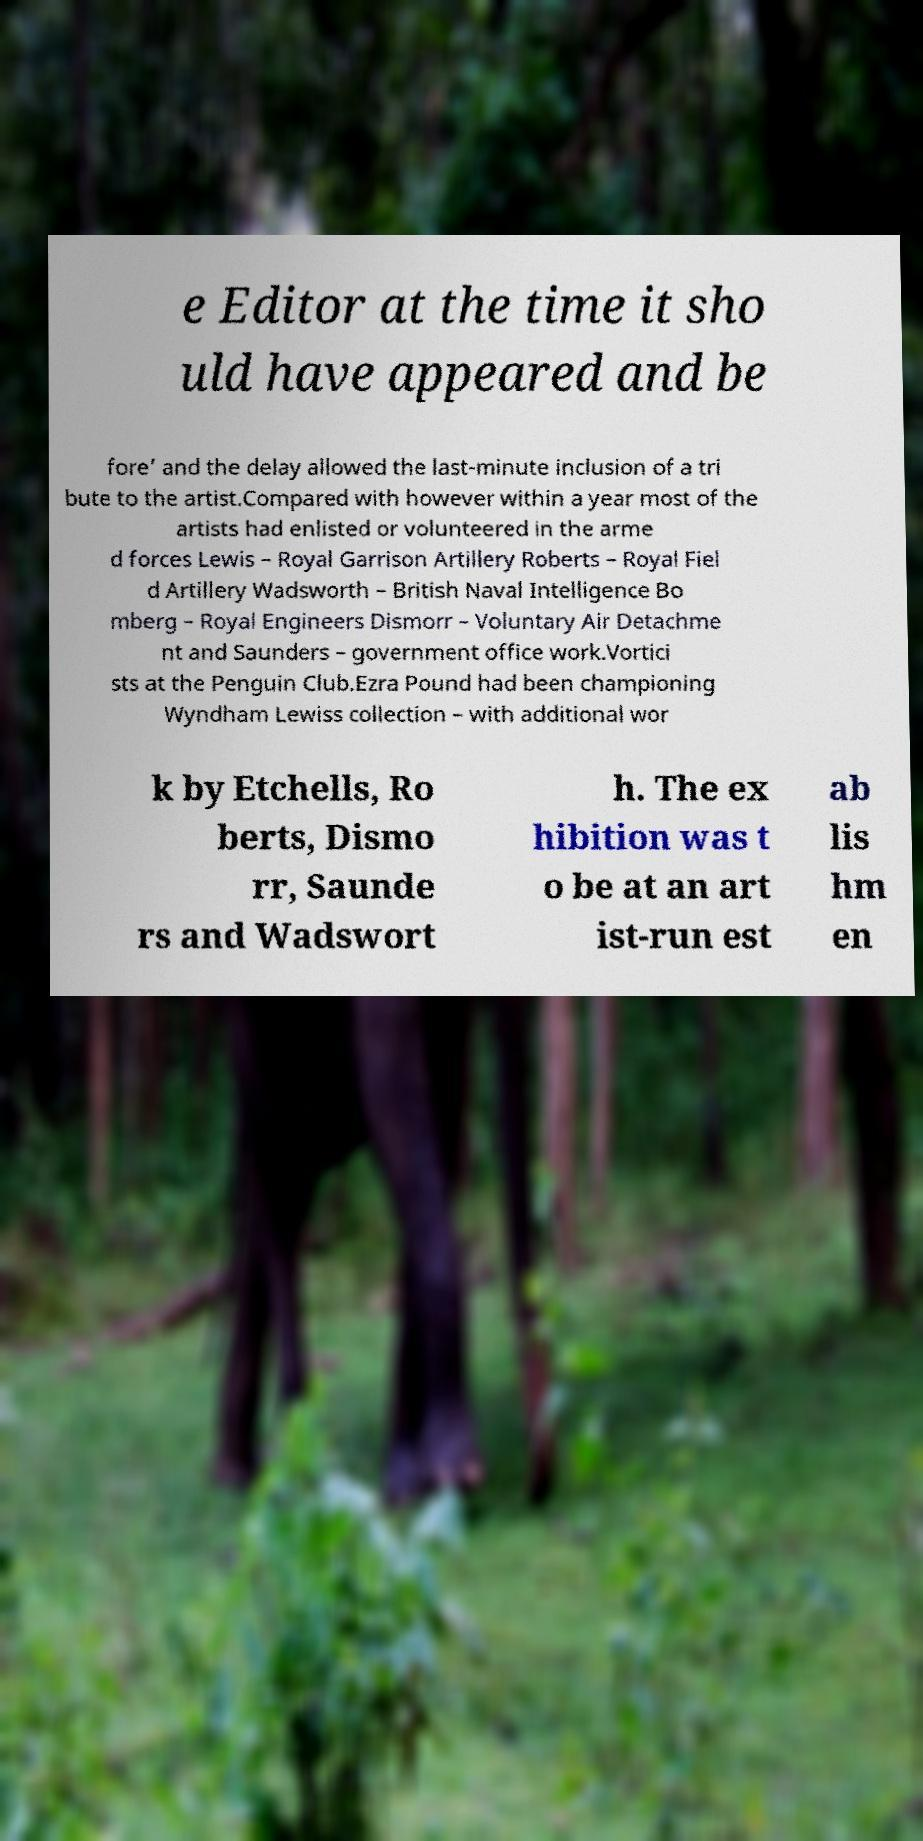Please identify and transcribe the text found in this image. e Editor at the time it sho uld have appeared and be fore’ and the delay allowed the last-minute inclusion of a tri bute to the artist.Compared with however within a year most of the artists had enlisted or volunteered in the arme d forces Lewis – Royal Garrison Artillery Roberts – Royal Fiel d Artillery Wadsworth – British Naval Intelligence Bo mberg – Royal Engineers Dismorr – Voluntary Air Detachme nt and Saunders – government office work.Vortici sts at the Penguin Club.Ezra Pound had been championing Wyndham Lewiss collection – with additional wor k by Etchells, Ro berts, Dismo rr, Saunde rs and Wadswort h. The ex hibition was t o be at an art ist-run est ab lis hm en 